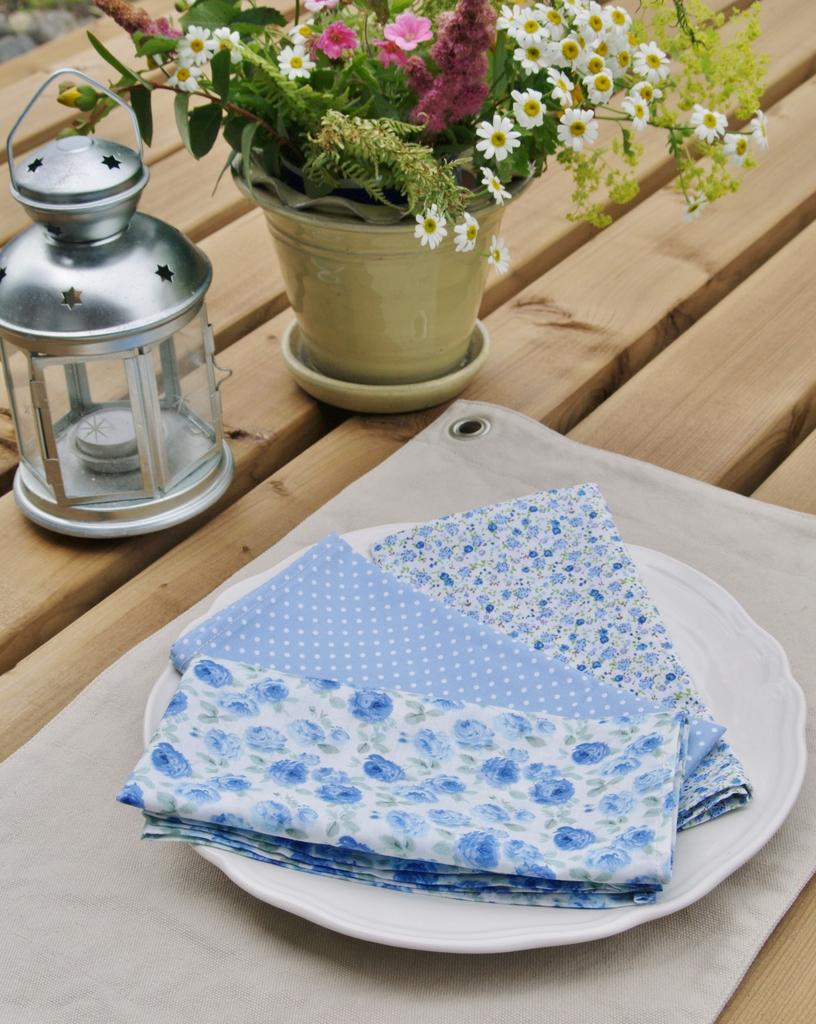What is the main object on the table in the image? There is a plate in the image. What other objects can be seen on the table? There is a flower vase and a candle in the image. What is the purpose of the flower vase? The flower vase is likely used for holding flowers. What is the purpose of the candle? The candle may be used for providing light or creating a certain ambiance. What is the income of the person who requested these items for the table? There is no information about the person's income or any request for these items in the image. 